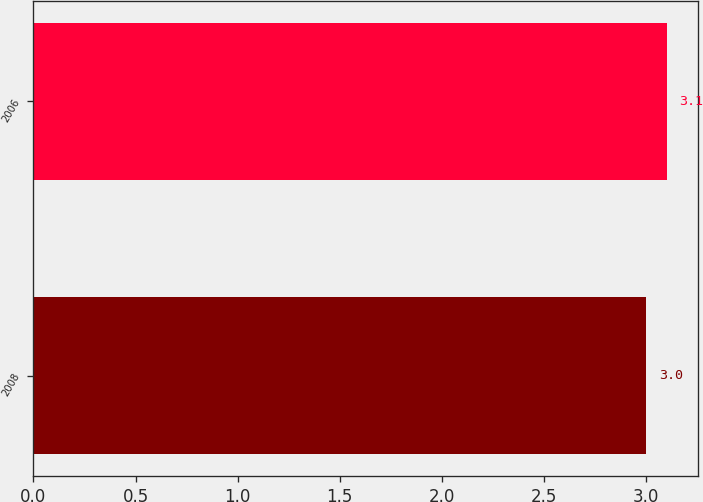<chart> <loc_0><loc_0><loc_500><loc_500><bar_chart><fcel>2008<fcel>2006<nl><fcel>3<fcel>3.1<nl></chart> 